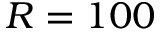<formula> <loc_0><loc_0><loc_500><loc_500>R = 1 0 0</formula> 